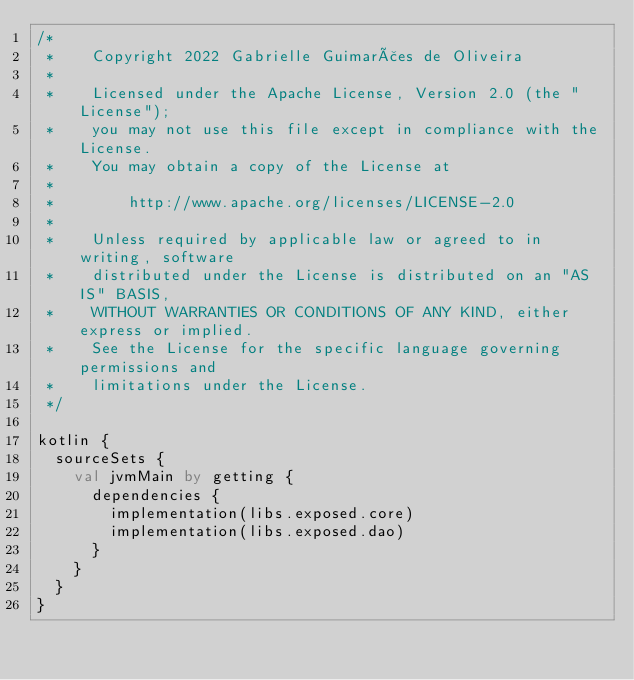<code> <loc_0><loc_0><loc_500><loc_500><_Kotlin_>/*
 *    Copyright 2022 Gabrielle Guimarães de Oliveira
 *
 *    Licensed under the Apache License, Version 2.0 (the "License");
 *    you may not use this file except in compliance with the License.
 *    You may obtain a copy of the License at
 *
 *        http://www.apache.org/licenses/LICENSE-2.0
 *
 *    Unless required by applicable law or agreed to in writing, software
 *    distributed under the License is distributed on an "AS IS" BASIS,
 *    WITHOUT WARRANTIES OR CONDITIONS OF ANY KIND, either express or implied.
 *    See the License for the specific language governing permissions and
 *    limitations under the License.
 */

kotlin {
  sourceSets {
    val jvmMain by getting {
      dependencies {
        implementation(libs.exposed.core)
        implementation(libs.exposed.dao)
      }
    }
  }
}
</code> 